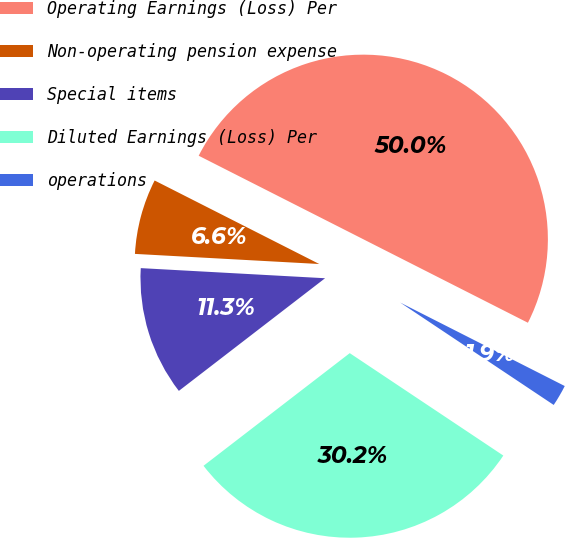Convert chart to OTSL. <chart><loc_0><loc_0><loc_500><loc_500><pie_chart><fcel>Operating Earnings (Loss) Per<fcel>Non-operating pension expense<fcel>Special items<fcel>Diluted Earnings (Loss) Per<fcel>operations<nl><fcel>50.0%<fcel>6.6%<fcel>11.32%<fcel>30.19%<fcel>1.89%<nl></chart> 